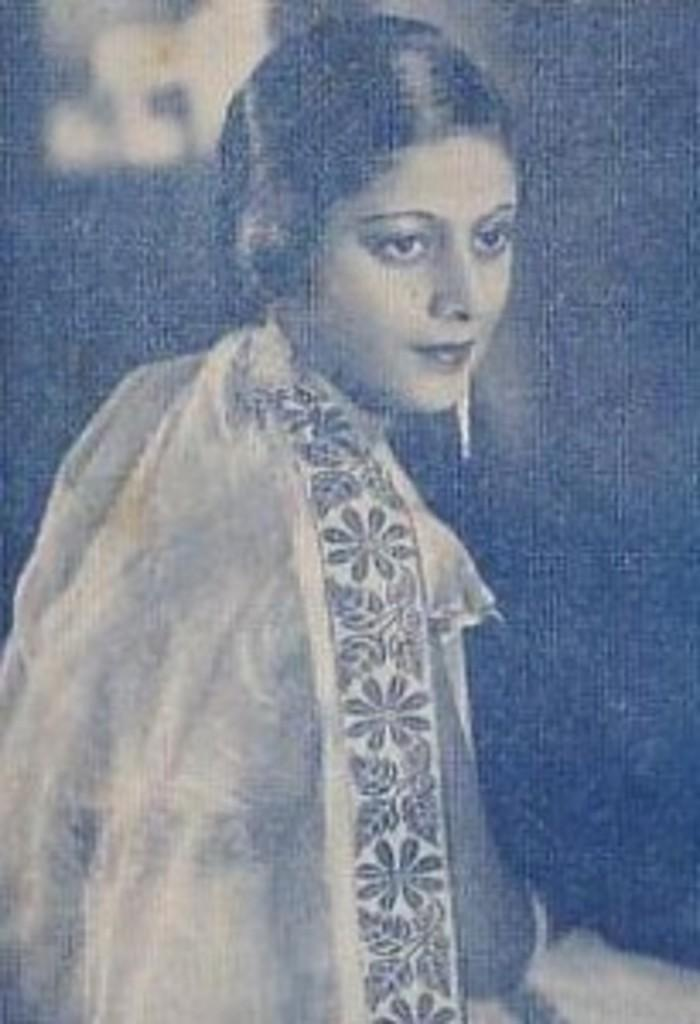What type of picture is in the image? The image contains a black and white picture. What is depicted in the black and white picture? The picture is of a person. Where is the fire located in the image? There is no fire present in the image. What type of furniture is visible in the image? The image does not show any furniture, such as a desk. 